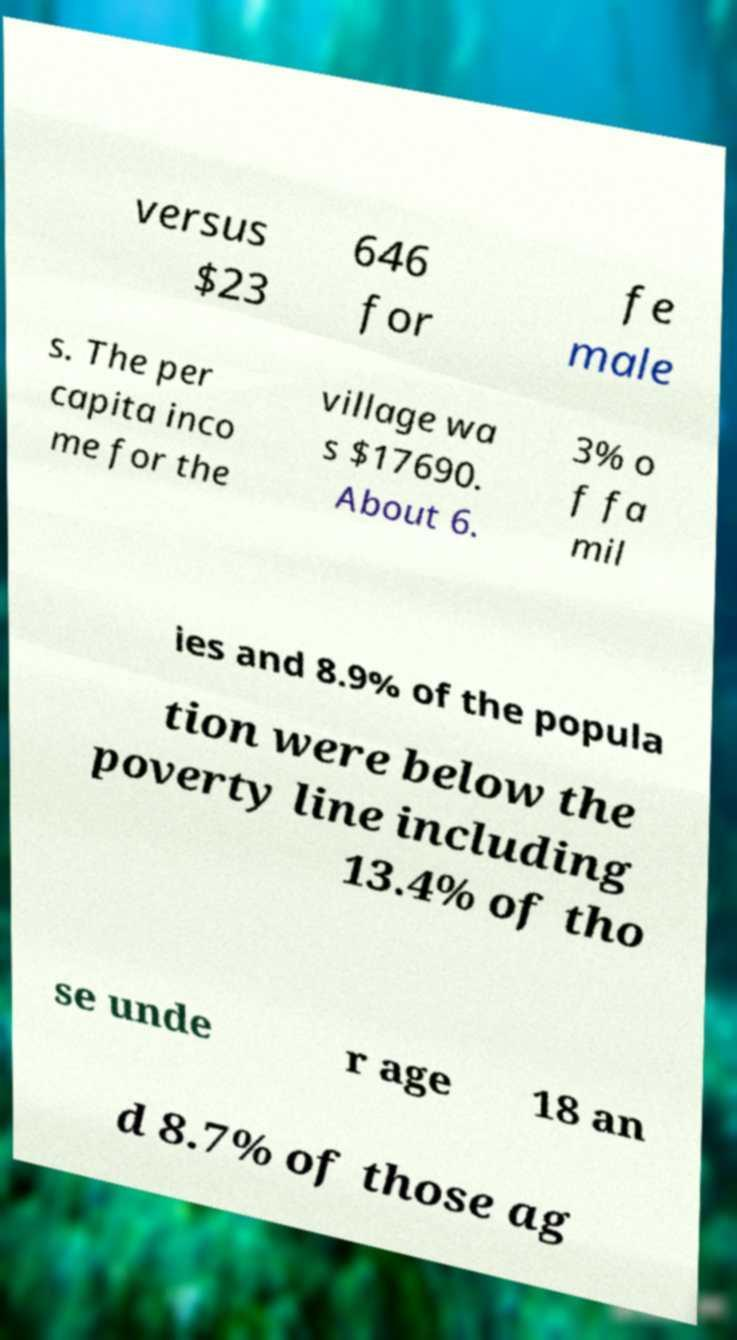Could you extract and type out the text from this image? versus $23 646 for fe male s. The per capita inco me for the village wa s $17690. About 6. 3% o f fa mil ies and 8.9% of the popula tion were below the poverty line including 13.4% of tho se unde r age 18 an d 8.7% of those ag 